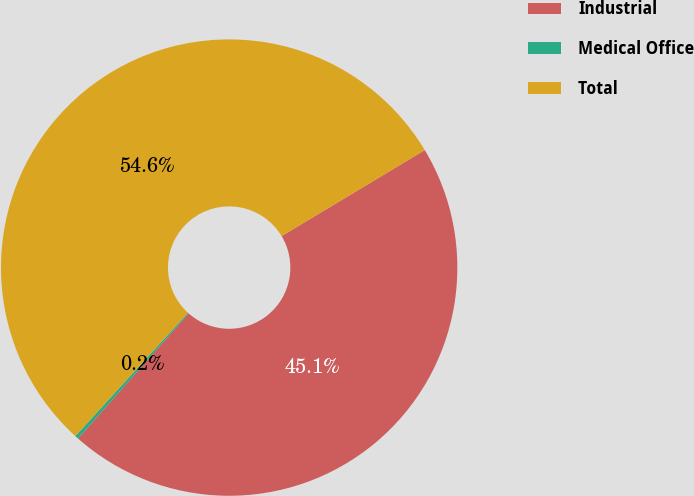Convert chart to OTSL. <chart><loc_0><loc_0><loc_500><loc_500><pie_chart><fcel>Industrial<fcel>Medical Office<fcel>Total<nl><fcel>45.13%<fcel>0.25%<fcel>54.62%<nl></chart> 